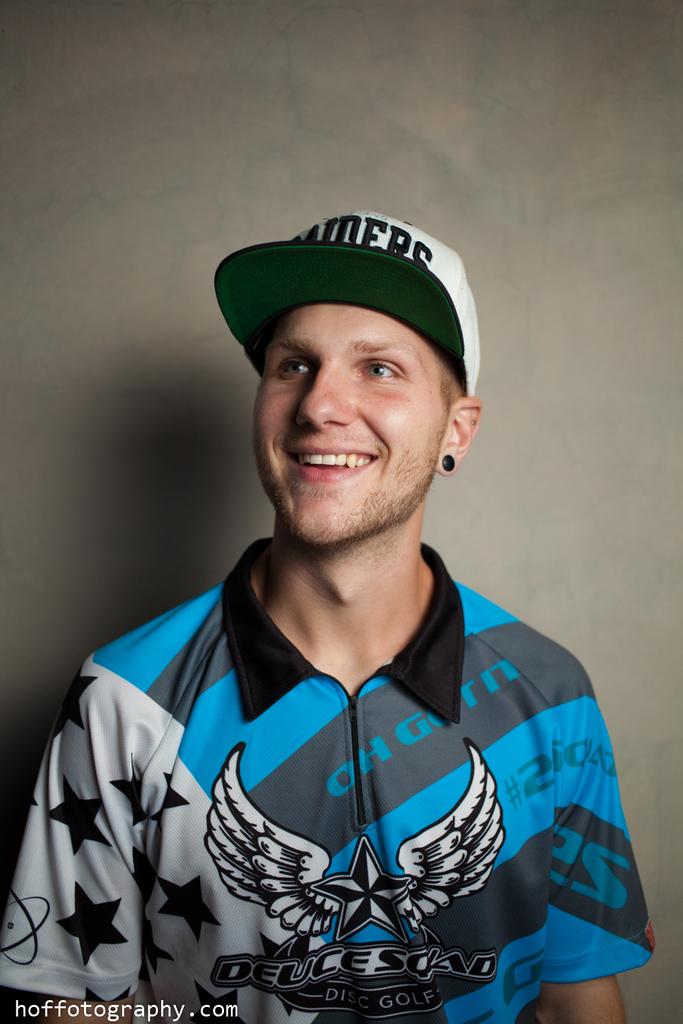What is website name for the photographer?
Provide a succinct answer. Hoffotography.com. 